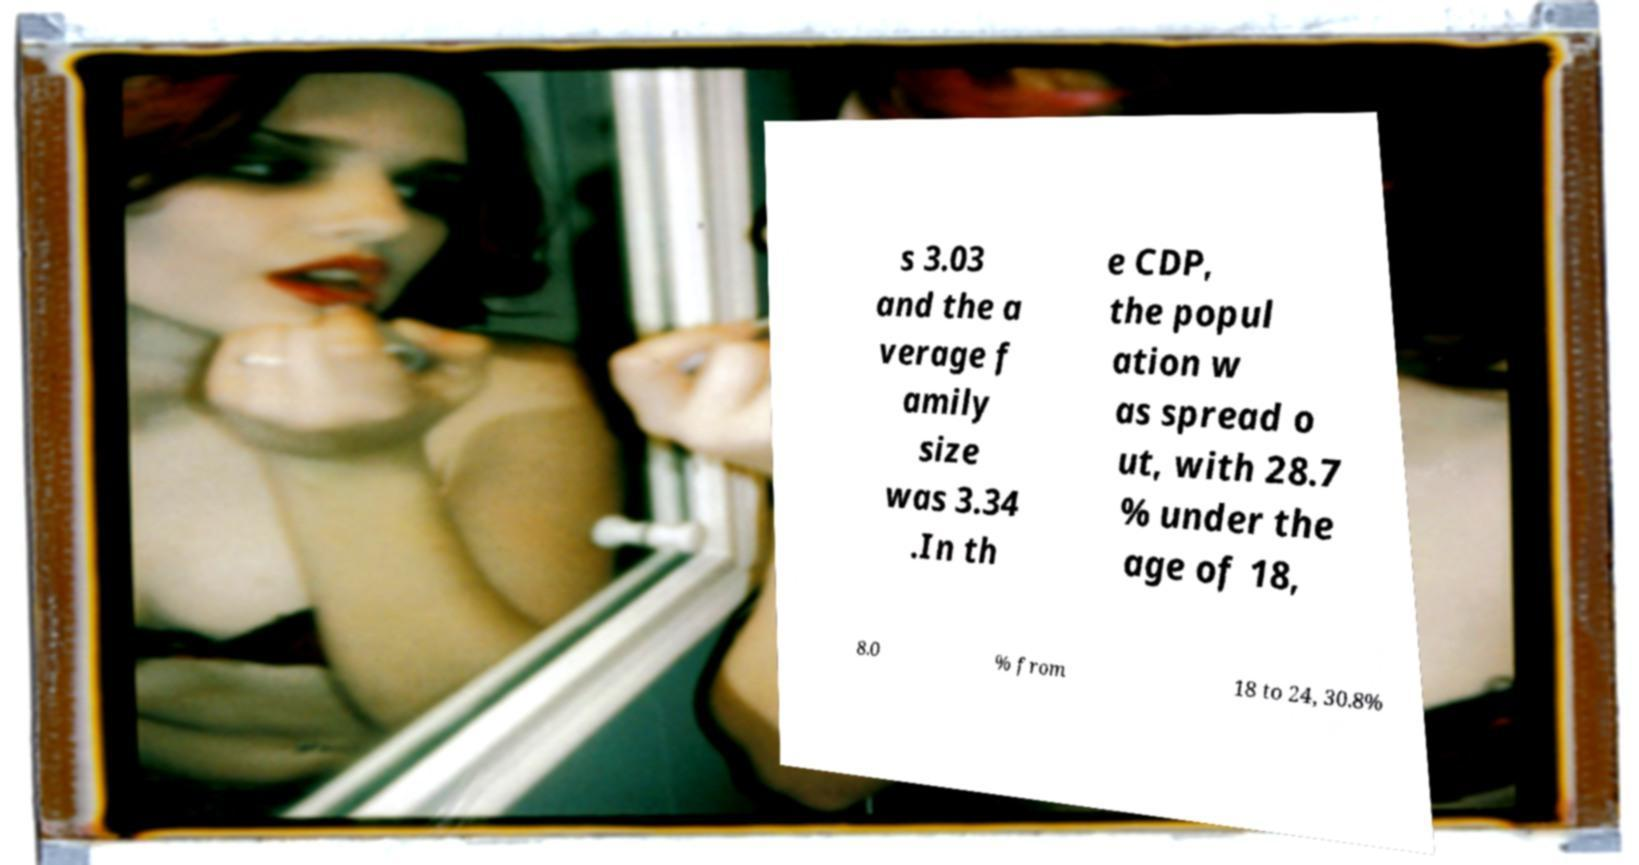I need the written content from this picture converted into text. Can you do that? s 3.03 and the a verage f amily size was 3.34 .In th e CDP, the popul ation w as spread o ut, with 28.7 % under the age of 18, 8.0 % from 18 to 24, 30.8% 